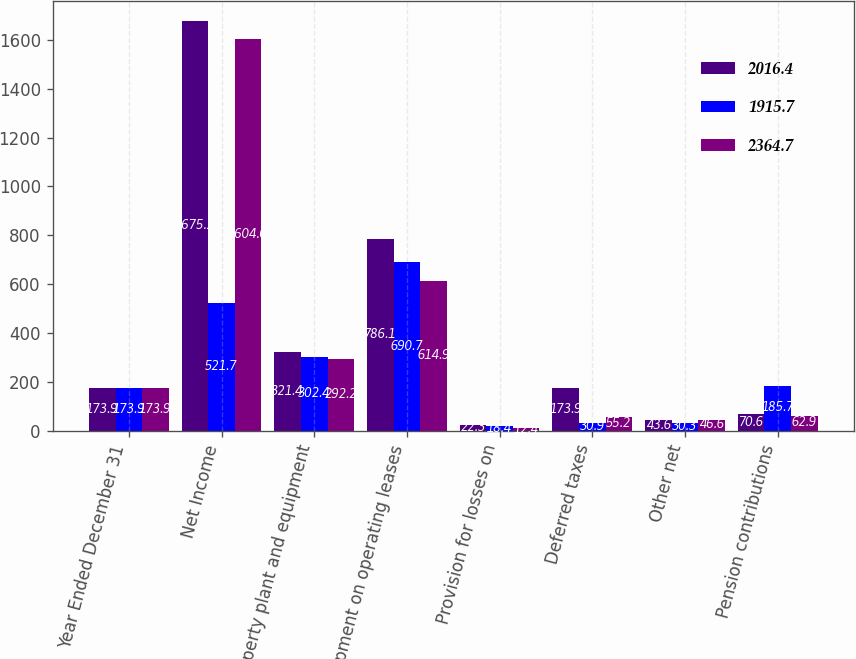<chart> <loc_0><loc_0><loc_500><loc_500><stacked_bar_chart><ecel><fcel>Year Ended December 31<fcel>Net Income<fcel>Property plant and equipment<fcel>Equipment on operating leases<fcel>Provision for losses on<fcel>Deferred taxes<fcel>Other net<fcel>Pension contributions<nl><fcel>2016.4<fcel>173.9<fcel>1675.2<fcel>321.4<fcel>786.1<fcel>22.3<fcel>173.9<fcel>43.6<fcel>70.6<nl><fcel>1915.7<fcel>173.9<fcel>521.7<fcel>302.4<fcel>690.7<fcel>18.4<fcel>30.9<fcel>30.3<fcel>185.7<nl><fcel>2364.7<fcel>173.9<fcel>1604<fcel>292.2<fcel>614.9<fcel>12.4<fcel>55.2<fcel>46.6<fcel>62.9<nl></chart> 